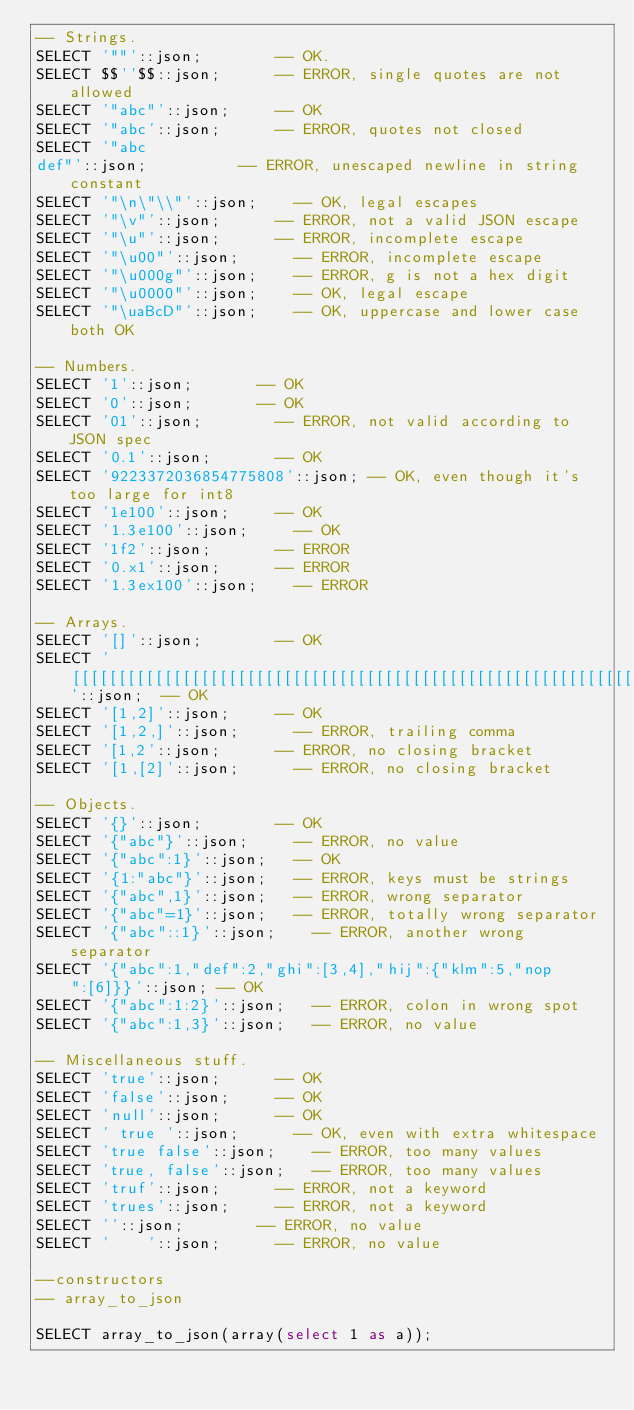Convert code to text. <code><loc_0><loc_0><loc_500><loc_500><_SQL_>-- Strings.
SELECT '""'::json;				-- OK.
SELECT $$''$$::json;			-- ERROR, single quotes are not allowed
SELECT '"abc"'::json;			-- OK
SELECT '"abc'::json;			-- ERROR, quotes not closed
SELECT '"abc
def"'::json;					-- ERROR, unescaped newline in string constant
SELECT '"\n\"\\"'::json;		-- OK, legal escapes
SELECT '"\v"'::json;			-- ERROR, not a valid JSON escape
SELECT '"\u"'::json;			-- ERROR, incomplete escape
SELECT '"\u00"'::json;			-- ERROR, incomplete escape
SELECT '"\u000g"'::json;		-- ERROR, g is not a hex digit
SELECT '"\u0000"'::json;		-- OK, legal escape
SELECT '"\uaBcD"'::json;		-- OK, uppercase and lower case both OK

-- Numbers.
SELECT '1'::json;				-- OK
SELECT '0'::json;				-- OK
SELECT '01'::json;				-- ERROR, not valid according to JSON spec
SELECT '0.1'::json;				-- OK
SELECT '9223372036854775808'::json;	-- OK, even though it's too large for int8
SELECT '1e100'::json;			-- OK
SELECT '1.3e100'::json;			-- OK
SELECT '1f2'::json;				-- ERROR
SELECT '0.x1'::json;			-- ERROR
SELECT '1.3ex100'::json;		-- ERROR

-- Arrays.
SELECT '[]'::json;				-- OK
SELECT '[[[[[[[[[[[[[[[[[[[[[[[[[[[[[[[[[[[[[[[[[[[[[[[[[[[[[[[[[[[[[[[[[[[[[[[[[[[[[[[[[[[[[[[[[[[[[[[[[[[[]]]]]]]]]]]]]]]]]]]]]]]]]]]]]]]]]]]]]]]]]]]]]]]]]]]]]]]]]]]]]]]]]]]]]]]]]]]]]]]]]]]]]]]]]]]]]]]]]]]]'::json;  -- OK
SELECT '[1,2]'::json;			-- OK
SELECT '[1,2,]'::json;			-- ERROR, trailing comma
SELECT '[1,2'::json;			-- ERROR, no closing bracket
SELECT '[1,[2]'::json;			-- ERROR, no closing bracket

-- Objects.
SELECT '{}'::json;				-- OK
SELECT '{"abc"}'::json;			-- ERROR, no value
SELECT '{"abc":1}'::json;		-- OK
SELECT '{1:"abc"}'::json;		-- ERROR, keys must be strings
SELECT '{"abc",1}'::json;		-- ERROR, wrong separator
SELECT '{"abc"=1}'::json;		-- ERROR, totally wrong separator
SELECT '{"abc"::1}'::json;		-- ERROR, another wrong separator
SELECT '{"abc":1,"def":2,"ghi":[3,4],"hij":{"klm":5,"nop":[6]}}'::json; -- OK
SELECT '{"abc":1:2}'::json;		-- ERROR, colon in wrong spot
SELECT '{"abc":1,3}'::json;		-- ERROR, no value

-- Miscellaneous stuff.
SELECT 'true'::json;			-- OK
SELECT 'false'::json;			-- OK
SELECT 'null'::json;			-- OK
SELECT ' true '::json;			-- OK, even with extra whitespace
SELECT 'true false'::json;		-- ERROR, too many values
SELECT 'true, false'::json;		-- ERROR, too many values
SELECT 'truf'::json;			-- ERROR, not a keyword
SELECT 'trues'::json;			-- ERROR, not a keyword
SELECT ''::json;				-- ERROR, no value
SELECT '    '::json;			-- ERROR, no value

--constructors
-- array_to_json

SELECT array_to_json(array(select 1 as a));</code> 